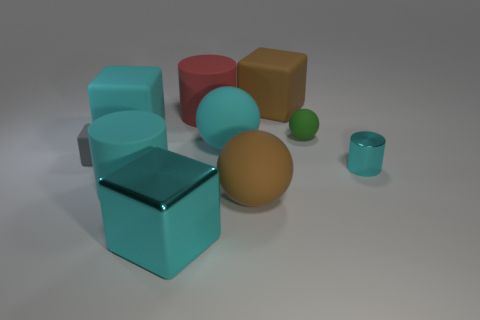Subtract all cyan cubes. How many were subtracted if there are1cyan cubes left? 1 Subtract all tiny cubes. How many cubes are left? 3 Subtract all cyan cubes. How many cyan cylinders are left? 2 Subtract 1 spheres. How many spheres are left? 2 Subtract all brown blocks. How many blocks are left? 3 Subtract all purple cylinders. Subtract all blue spheres. How many cylinders are left? 3 Subtract all balls. How many objects are left? 7 Subtract all shiny things. Subtract all big brown cubes. How many objects are left? 7 Add 3 big cyan shiny cubes. How many big cyan shiny cubes are left? 4 Add 1 small green metal cylinders. How many small green metal cylinders exist? 1 